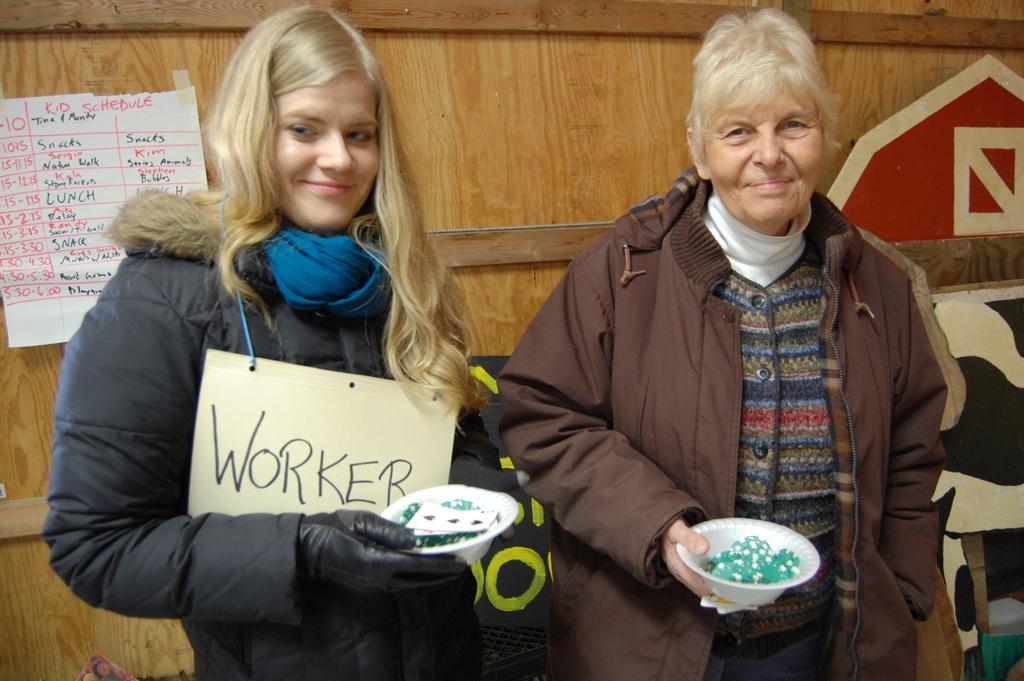Please provide a concise description of this image. In this image I can see two people are standing and holding white bowls. They are wearing blue and brown color jackets. Back I can see the wooden object and white paper is attached to it. 